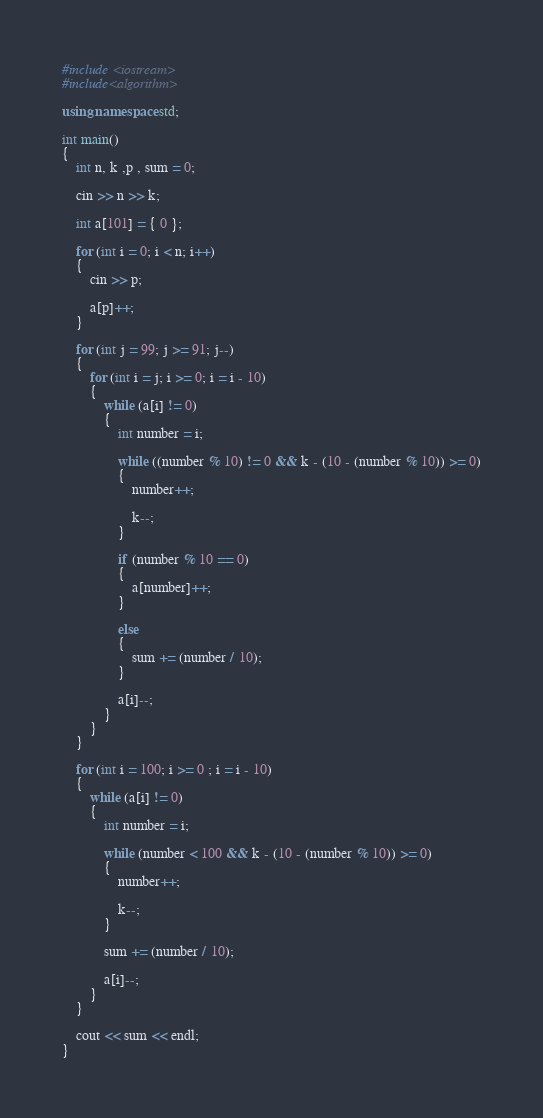<code> <loc_0><loc_0><loc_500><loc_500><_C++_>#include <iostream>
#include<algorithm>

using namespace std;

int main()
{
	int n, k ,p , sum = 0;

	cin >> n >> k;

	int a[101] = { 0 };

	for (int i = 0; i < n; i++)
	{
		cin >> p;

		a[p]++;
	}

	for (int j = 99; j >= 91; j--)
	{
		for (int i = j; i >= 0; i = i - 10)
		{
			while (a[i] != 0)
			{
				int number = i;

				while ((number % 10) != 0 && k - (10 - (number % 10)) >= 0)
				{
					number++;

					k--;
				}

				if (number % 10 == 0)
				{
					a[number]++;
				}
				
				else
				{
					sum += (number / 10);
				}

				a[i]--;
			}
		}
	}

	for (int i = 100; i >= 0 ; i = i - 10)
	{
		while (a[i] != 0)
		{
			int number = i;

			while (number < 100 && k - (10 - (number % 10)) >= 0)
			{
				number++;

				k--;
			}

			sum += (number / 10);

			a[i]--;
		}
	}

	cout << sum << endl;
}
</code> 